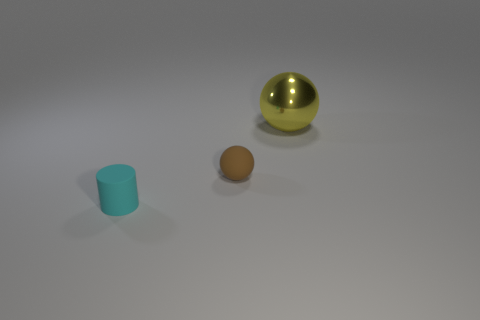What colors are the objects in the picture, and how would you describe their positions relative to each other? The image displays three objects: a gold-colored large shiny sphere, a small brown cylinder, and a yellow ball. The gold sphere is located to the right and slightly behind the yellow ball from the viewer's perspective, while the small cylinder is positioned to the left and in front of the yellow ball. 